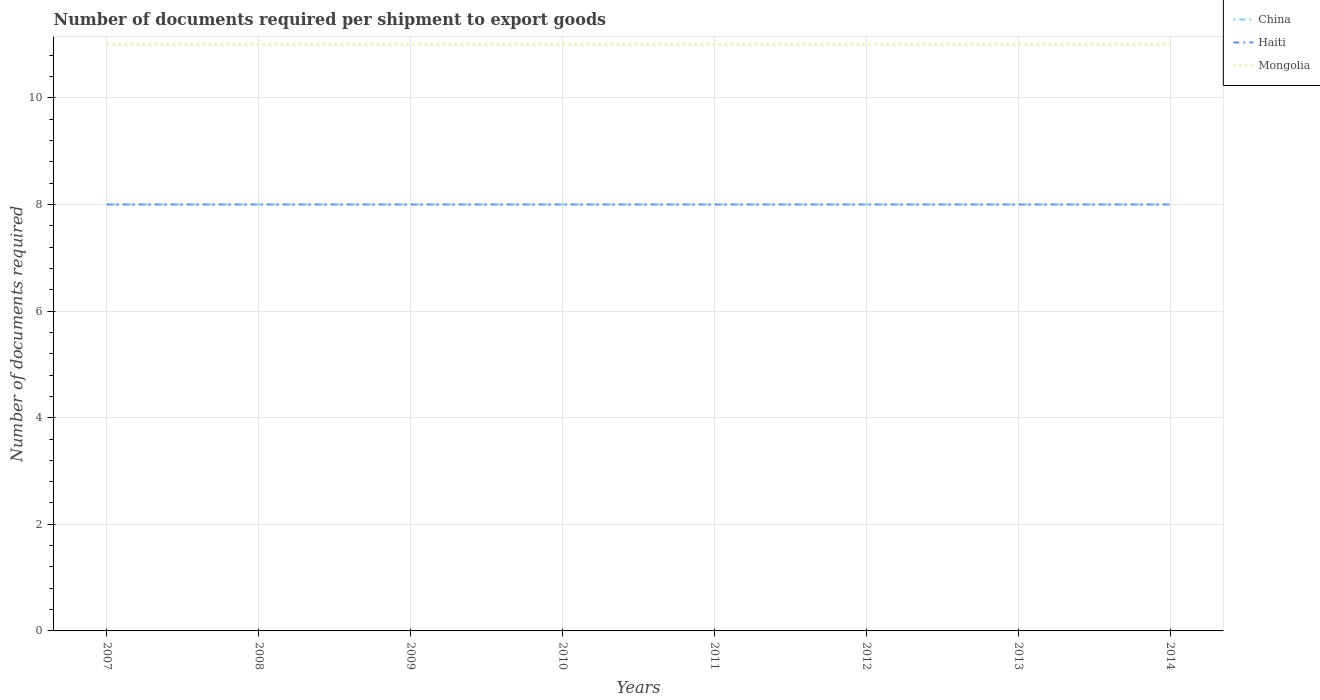Does the line corresponding to Mongolia intersect with the line corresponding to Haiti?
Offer a terse response. No. Is the number of lines equal to the number of legend labels?
Make the answer very short. Yes. Across all years, what is the maximum number of documents required per shipment to export goods in Mongolia?
Your response must be concise. 11. What is the total number of documents required per shipment to export goods in Mongolia in the graph?
Make the answer very short. 0. What is the difference between the highest and the second highest number of documents required per shipment to export goods in Haiti?
Provide a succinct answer. 0. What is the difference between the highest and the lowest number of documents required per shipment to export goods in Mongolia?
Provide a succinct answer. 0. Is the number of documents required per shipment to export goods in China strictly greater than the number of documents required per shipment to export goods in Haiti over the years?
Keep it short and to the point. No. How many lines are there?
Ensure brevity in your answer.  3. How many years are there in the graph?
Provide a short and direct response. 8. What is the difference between two consecutive major ticks on the Y-axis?
Give a very brief answer. 2. Does the graph contain any zero values?
Your answer should be compact. No. Does the graph contain grids?
Provide a succinct answer. Yes. Where does the legend appear in the graph?
Offer a very short reply. Top right. How are the legend labels stacked?
Offer a very short reply. Vertical. What is the title of the graph?
Provide a succinct answer. Number of documents required per shipment to export goods. Does "El Salvador" appear as one of the legend labels in the graph?
Give a very brief answer. No. What is the label or title of the Y-axis?
Provide a succinct answer. Number of documents required. What is the Number of documents required in China in 2007?
Your answer should be very brief. 8. What is the Number of documents required in Haiti in 2007?
Provide a succinct answer. 8. What is the Number of documents required of China in 2008?
Make the answer very short. 8. What is the Number of documents required of Haiti in 2008?
Give a very brief answer. 8. What is the Number of documents required of China in 2009?
Offer a terse response. 8. What is the Number of documents required of Haiti in 2009?
Keep it short and to the point. 8. What is the Number of documents required of China in 2010?
Make the answer very short. 8. What is the Number of documents required in China in 2011?
Offer a very short reply. 8. What is the Number of documents required of China in 2012?
Your answer should be compact. 8. What is the Number of documents required in Haiti in 2012?
Your response must be concise. 8. What is the Number of documents required of Mongolia in 2012?
Offer a very short reply. 11. What is the Number of documents required of China in 2013?
Ensure brevity in your answer.  8. What is the Number of documents required of Mongolia in 2013?
Keep it short and to the point. 11. What is the Number of documents required in China in 2014?
Offer a very short reply. 8. What is the Number of documents required of Haiti in 2014?
Keep it short and to the point. 8. What is the Number of documents required of Mongolia in 2014?
Your answer should be very brief. 11. Across all years, what is the maximum Number of documents required in Mongolia?
Provide a short and direct response. 11. Across all years, what is the minimum Number of documents required in China?
Your answer should be compact. 8. Across all years, what is the minimum Number of documents required of Haiti?
Provide a succinct answer. 8. What is the difference between the Number of documents required in Haiti in 2007 and that in 2008?
Make the answer very short. 0. What is the difference between the Number of documents required of Haiti in 2007 and that in 2009?
Ensure brevity in your answer.  0. What is the difference between the Number of documents required in Mongolia in 2007 and that in 2009?
Provide a succinct answer. 0. What is the difference between the Number of documents required of China in 2007 and that in 2010?
Ensure brevity in your answer.  0. What is the difference between the Number of documents required of Haiti in 2007 and that in 2010?
Provide a short and direct response. 0. What is the difference between the Number of documents required of China in 2007 and that in 2011?
Give a very brief answer. 0. What is the difference between the Number of documents required of Mongolia in 2007 and that in 2013?
Keep it short and to the point. 0. What is the difference between the Number of documents required in China in 2008 and that in 2009?
Ensure brevity in your answer.  0. What is the difference between the Number of documents required of China in 2008 and that in 2010?
Ensure brevity in your answer.  0. What is the difference between the Number of documents required in Mongolia in 2008 and that in 2010?
Your answer should be compact. 0. What is the difference between the Number of documents required of China in 2008 and that in 2012?
Offer a very short reply. 0. What is the difference between the Number of documents required of Haiti in 2008 and that in 2012?
Your answer should be very brief. 0. What is the difference between the Number of documents required in Mongolia in 2008 and that in 2012?
Offer a terse response. 0. What is the difference between the Number of documents required in China in 2009 and that in 2010?
Keep it short and to the point. 0. What is the difference between the Number of documents required in Haiti in 2009 and that in 2010?
Provide a short and direct response. 0. What is the difference between the Number of documents required in Haiti in 2009 and that in 2011?
Give a very brief answer. 0. What is the difference between the Number of documents required of China in 2009 and that in 2012?
Make the answer very short. 0. What is the difference between the Number of documents required of Haiti in 2009 and that in 2012?
Provide a short and direct response. 0. What is the difference between the Number of documents required in Mongolia in 2009 and that in 2012?
Offer a terse response. 0. What is the difference between the Number of documents required of Mongolia in 2009 and that in 2013?
Keep it short and to the point. 0. What is the difference between the Number of documents required of Mongolia in 2009 and that in 2014?
Offer a terse response. 0. What is the difference between the Number of documents required of China in 2010 and that in 2011?
Your answer should be compact. 0. What is the difference between the Number of documents required of Mongolia in 2010 and that in 2012?
Offer a very short reply. 0. What is the difference between the Number of documents required in China in 2010 and that in 2013?
Your answer should be compact. 0. What is the difference between the Number of documents required in Haiti in 2010 and that in 2013?
Give a very brief answer. 0. What is the difference between the Number of documents required in China in 2010 and that in 2014?
Your response must be concise. 0. What is the difference between the Number of documents required of Haiti in 2010 and that in 2014?
Ensure brevity in your answer.  0. What is the difference between the Number of documents required of China in 2011 and that in 2012?
Provide a succinct answer. 0. What is the difference between the Number of documents required in Mongolia in 2011 and that in 2014?
Offer a terse response. 0. What is the difference between the Number of documents required of Mongolia in 2012 and that in 2013?
Your response must be concise. 0. What is the difference between the Number of documents required in Mongolia in 2012 and that in 2014?
Offer a very short reply. 0. What is the difference between the Number of documents required in China in 2013 and that in 2014?
Your response must be concise. 0. What is the difference between the Number of documents required in Mongolia in 2013 and that in 2014?
Offer a terse response. 0. What is the difference between the Number of documents required of China in 2007 and the Number of documents required of Haiti in 2008?
Your answer should be very brief. 0. What is the difference between the Number of documents required of China in 2007 and the Number of documents required of Mongolia in 2008?
Offer a terse response. -3. What is the difference between the Number of documents required in China in 2007 and the Number of documents required in Haiti in 2009?
Your answer should be very brief. 0. What is the difference between the Number of documents required in China in 2007 and the Number of documents required in Haiti in 2011?
Give a very brief answer. 0. What is the difference between the Number of documents required in China in 2007 and the Number of documents required in Haiti in 2012?
Make the answer very short. 0. What is the difference between the Number of documents required of Haiti in 2007 and the Number of documents required of Mongolia in 2012?
Your answer should be very brief. -3. What is the difference between the Number of documents required of China in 2007 and the Number of documents required of Mongolia in 2013?
Ensure brevity in your answer.  -3. What is the difference between the Number of documents required in Haiti in 2007 and the Number of documents required in Mongolia in 2013?
Ensure brevity in your answer.  -3. What is the difference between the Number of documents required of China in 2007 and the Number of documents required of Mongolia in 2014?
Provide a short and direct response. -3. What is the difference between the Number of documents required of Haiti in 2007 and the Number of documents required of Mongolia in 2014?
Your answer should be compact. -3. What is the difference between the Number of documents required in Haiti in 2008 and the Number of documents required in Mongolia in 2009?
Ensure brevity in your answer.  -3. What is the difference between the Number of documents required of China in 2008 and the Number of documents required of Haiti in 2010?
Your answer should be very brief. 0. What is the difference between the Number of documents required of China in 2008 and the Number of documents required of Mongolia in 2010?
Your answer should be very brief. -3. What is the difference between the Number of documents required of China in 2008 and the Number of documents required of Haiti in 2011?
Keep it short and to the point. 0. What is the difference between the Number of documents required of China in 2008 and the Number of documents required of Mongolia in 2011?
Keep it short and to the point. -3. What is the difference between the Number of documents required of Haiti in 2008 and the Number of documents required of Mongolia in 2011?
Your response must be concise. -3. What is the difference between the Number of documents required of China in 2008 and the Number of documents required of Haiti in 2012?
Provide a short and direct response. 0. What is the difference between the Number of documents required of China in 2008 and the Number of documents required of Mongolia in 2012?
Offer a terse response. -3. What is the difference between the Number of documents required in Haiti in 2008 and the Number of documents required in Mongolia in 2012?
Give a very brief answer. -3. What is the difference between the Number of documents required in China in 2008 and the Number of documents required in Mongolia in 2014?
Make the answer very short. -3. What is the difference between the Number of documents required of China in 2009 and the Number of documents required of Mongolia in 2010?
Keep it short and to the point. -3. What is the difference between the Number of documents required in China in 2009 and the Number of documents required in Mongolia in 2011?
Offer a terse response. -3. What is the difference between the Number of documents required of Haiti in 2009 and the Number of documents required of Mongolia in 2011?
Ensure brevity in your answer.  -3. What is the difference between the Number of documents required in China in 2009 and the Number of documents required in Haiti in 2012?
Your answer should be compact. 0. What is the difference between the Number of documents required of China in 2009 and the Number of documents required of Mongolia in 2012?
Provide a succinct answer. -3. What is the difference between the Number of documents required of Haiti in 2009 and the Number of documents required of Mongolia in 2012?
Offer a terse response. -3. What is the difference between the Number of documents required of China in 2009 and the Number of documents required of Haiti in 2013?
Provide a short and direct response. 0. What is the difference between the Number of documents required of China in 2009 and the Number of documents required of Mongolia in 2013?
Provide a short and direct response. -3. What is the difference between the Number of documents required in China in 2009 and the Number of documents required in Mongolia in 2014?
Ensure brevity in your answer.  -3. What is the difference between the Number of documents required in Haiti in 2009 and the Number of documents required in Mongolia in 2014?
Provide a succinct answer. -3. What is the difference between the Number of documents required in China in 2010 and the Number of documents required in Haiti in 2012?
Make the answer very short. 0. What is the difference between the Number of documents required in China in 2010 and the Number of documents required in Mongolia in 2012?
Ensure brevity in your answer.  -3. What is the difference between the Number of documents required in Haiti in 2010 and the Number of documents required in Mongolia in 2014?
Offer a terse response. -3. What is the difference between the Number of documents required of China in 2011 and the Number of documents required of Mongolia in 2012?
Offer a terse response. -3. What is the difference between the Number of documents required of Haiti in 2011 and the Number of documents required of Mongolia in 2012?
Offer a very short reply. -3. What is the difference between the Number of documents required in China in 2011 and the Number of documents required in Haiti in 2013?
Give a very brief answer. 0. What is the difference between the Number of documents required in China in 2011 and the Number of documents required in Mongolia in 2014?
Give a very brief answer. -3. What is the difference between the Number of documents required of Haiti in 2011 and the Number of documents required of Mongolia in 2014?
Your answer should be very brief. -3. What is the difference between the Number of documents required of China in 2012 and the Number of documents required of Haiti in 2013?
Give a very brief answer. 0. What is the difference between the Number of documents required in Haiti in 2012 and the Number of documents required in Mongolia in 2013?
Offer a terse response. -3. What is the difference between the Number of documents required in China in 2012 and the Number of documents required in Haiti in 2014?
Offer a terse response. 0. What is the difference between the Number of documents required in China in 2012 and the Number of documents required in Mongolia in 2014?
Your response must be concise. -3. What is the difference between the Number of documents required of China in 2013 and the Number of documents required of Haiti in 2014?
Keep it short and to the point. 0. What is the difference between the Number of documents required in China in 2013 and the Number of documents required in Mongolia in 2014?
Offer a terse response. -3. What is the difference between the Number of documents required of Haiti in 2013 and the Number of documents required of Mongolia in 2014?
Give a very brief answer. -3. What is the average Number of documents required in Haiti per year?
Ensure brevity in your answer.  8. In the year 2007, what is the difference between the Number of documents required in China and Number of documents required in Haiti?
Offer a very short reply. 0. In the year 2007, what is the difference between the Number of documents required of China and Number of documents required of Mongolia?
Provide a short and direct response. -3. In the year 2007, what is the difference between the Number of documents required of Haiti and Number of documents required of Mongolia?
Provide a succinct answer. -3. In the year 2008, what is the difference between the Number of documents required of China and Number of documents required of Haiti?
Ensure brevity in your answer.  0. In the year 2008, what is the difference between the Number of documents required of China and Number of documents required of Mongolia?
Keep it short and to the point. -3. In the year 2008, what is the difference between the Number of documents required in Haiti and Number of documents required in Mongolia?
Provide a succinct answer. -3. In the year 2009, what is the difference between the Number of documents required of China and Number of documents required of Haiti?
Provide a succinct answer. 0. In the year 2009, what is the difference between the Number of documents required of China and Number of documents required of Mongolia?
Offer a very short reply. -3. In the year 2011, what is the difference between the Number of documents required of China and Number of documents required of Haiti?
Offer a terse response. 0. In the year 2011, what is the difference between the Number of documents required in China and Number of documents required in Mongolia?
Ensure brevity in your answer.  -3. In the year 2012, what is the difference between the Number of documents required of China and Number of documents required of Haiti?
Provide a short and direct response. 0. In the year 2012, what is the difference between the Number of documents required in China and Number of documents required in Mongolia?
Keep it short and to the point. -3. In the year 2013, what is the difference between the Number of documents required of China and Number of documents required of Haiti?
Provide a succinct answer. 0. In the year 2013, what is the difference between the Number of documents required in China and Number of documents required in Mongolia?
Keep it short and to the point. -3. In the year 2014, what is the difference between the Number of documents required in China and Number of documents required in Mongolia?
Make the answer very short. -3. In the year 2014, what is the difference between the Number of documents required of Haiti and Number of documents required of Mongolia?
Keep it short and to the point. -3. What is the ratio of the Number of documents required of China in 2007 to that in 2008?
Give a very brief answer. 1. What is the ratio of the Number of documents required in Haiti in 2007 to that in 2008?
Provide a short and direct response. 1. What is the ratio of the Number of documents required of China in 2007 to that in 2009?
Offer a very short reply. 1. What is the ratio of the Number of documents required of China in 2007 to that in 2010?
Offer a terse response. 1. What is the ratio of the Number of documents required in China in 2007 to that in 2012?
Your response must be concise. 1. What is the ratio of the Number of documents required in China in 2007 to that in 2014?
Ensure brevity in your answer.  1. What is the ratio of the Number of documents required of Mongolia in 2008 to that in 2009?
Keep it short and to the point. 1. What is the ratio of the Number of documents required in Haiti in 2008 to that in 2010?
Offer a terse response. 1. What is the ratio of the Number of documents required in China in 2008 to that in 2011?
Offer a very short reply. 1. What is the ratio of the Number of documents required of China in 2008 to that in 2012?
Your response must be concise. 1. What is the ratio of the Number of documents required of Mongolia in 2008 to that in 2012?
Offer a very short reply. 1. What is the ratio of the Number of documents required in China in 2008 to that in 2014?
Keep it short and to the point. 1. What is the ratio of the Number of documents required of Mongolia in 2008 to that in 2014?
Your answer should be compact. 1. What is the ratio of the Number of documents required of Haiti in 2009 to that in 2010?
Your response must be concise. 1. What is the ratio of the Number of documents required of China in 2009 to that in 2011?
Provide a succinct answer. 1. What is the ratio of the Number of documents required in Haiti in 2009 to that in 2011?
Give a very brief answer. 1. What is the ratio of the Number of documents required of Mongolia in 2009 to that in 2011?
Give a very brief answer. 1. What is the ratio of the Number of documents required of Mongolia in 2009 to that in 2012?
Ensure brevity in your answer.  1. What is the ratio of the Number of documents required of China in 2009 to that in 2013?
Make the answer very short. 1. What is the ratio of the Number of documents required in Mongolia in 2009 to that in 2014?
Offer a very short reply. 1. What is the ratio of the Number of documents required in Haiti in 2010 to that in 2013?
Your answer should be very brief. 1. What is the ratio of the Number of documents required in Mongolia in 2010 to that in 2013?
Provide a short and direct response. 1. What is the ratio of the Number of documents required in China in 2010 to that in 2014?
Keep it short and to the point. 1. What is the ratio of the Number of documents required of Haiti in 2010 to that in 2014?
Your response must be concise. 1. What is the ratio of the Number of documents required of Mongolia in 2010 to that in 2014?
Provide a succinct answer. 1. What is the ratio of the Number of documents required of China in 2011 to that in 2013?
Your answer should be compact. 1. What is the ratio of the Number of documents required of Mongolia in 2011 to that in 2013?
Offer a very short reply. 1. What is the ratio of the Number of documents required in China in 2011 to that in 2014?
Keep it short and to the point. 1. What is the ratio of the Number of documents required in Haiti in 2011 to that in 2014?
Your answer should be very brief. 1. What is the ratio of the Number of documents required of Mongolia in 2011 to that in 2014?
Keep it short and to the point. 1. What is the ratio of the Number of documents required of Haiti in 2012 to that in 2013?
Keep it short and to the point. 1. What is the ratio of the Number of documents required of Mongolia in 2012 to that in 2013?
Make the answer very short. 1. What is the ratio of the Number of documents required of Haiti in 2013 to that in 2014?
Your response must be concise. 1. What is the ratio of the Number of documents required of Mongolia in 2013 to that in 2014?
Give a very brief answer. 1. What is the difference between the highest and the second highest Number of documents required in China?
Offer a terse response. 0. What is the difference between the highest and the second highest Number of documents required of Haiti?
Keep it short and to the point. 0. What is the difference between the highest and the lowest Number of documents required in Haiti?
Ensure brevity in your answer.  0. What is the difference between the highest and the lowest Number of documents required in Mongolia?
Keep it short and to the point. 0. 